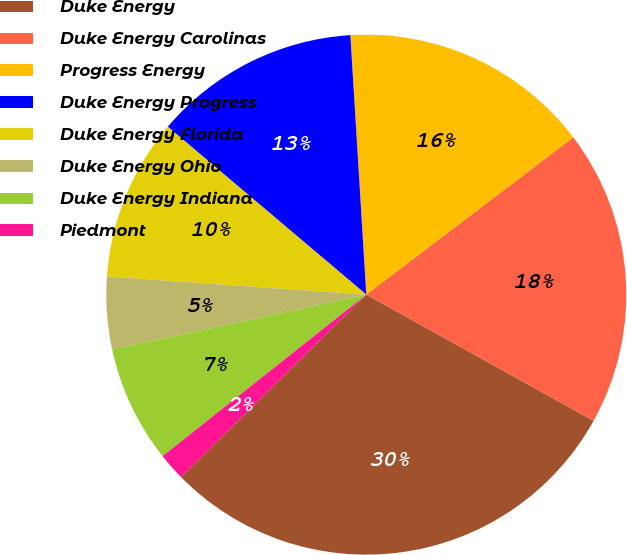<chart> <loc_0><loc_0><loc_500><loc_500><pie_chart><fcel>Duke Energy<fcel>Duke Energy Carolinas<fcel>Progress Energy<fcel>Duke Energy Progress<fcel>Duke Energy Florida<fcel>Duke Energy Ohio<fcel>Duke Energy Indiana<fcel>Piedmont<nl><fcel>29.55%<fcel>18.41%<fcel>15.63%<fcel>12.85%<fcel>10.06%<fcel>4.5%<fcel>7.28%<fcel>1.71%<nl></chart> 